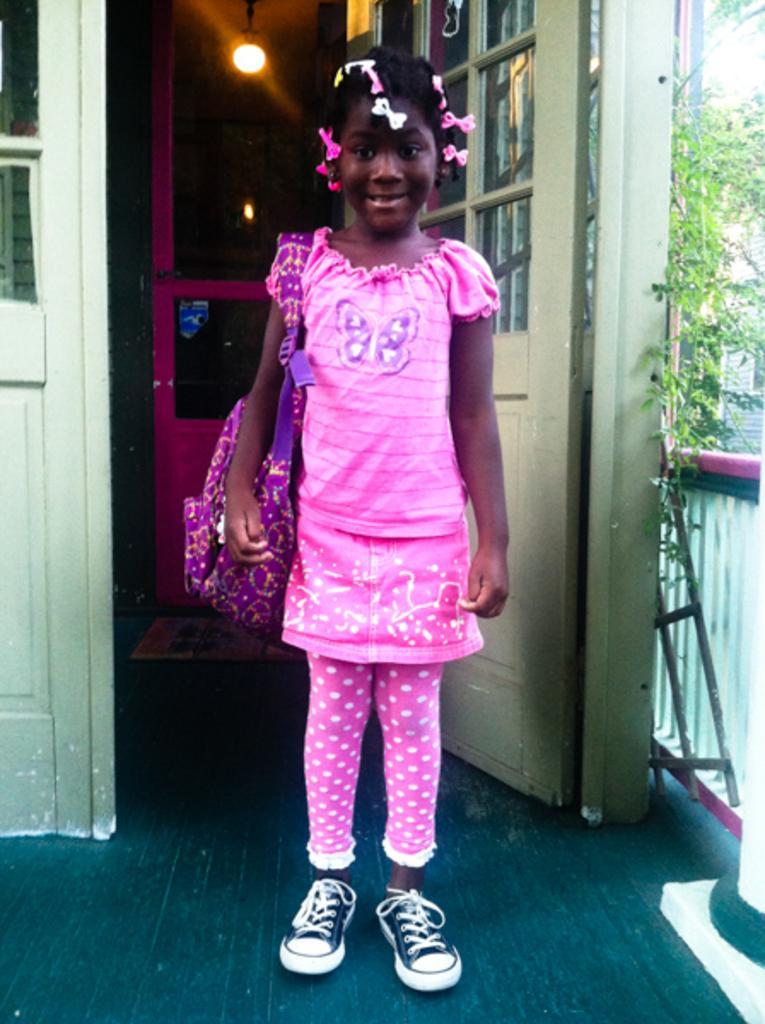In one or two sentences, can you explain what this image depicts? In this image we can see a girl standing on the floor and wearing a backpack. In the background we can see creepers, pillars, doors and an electric light. 